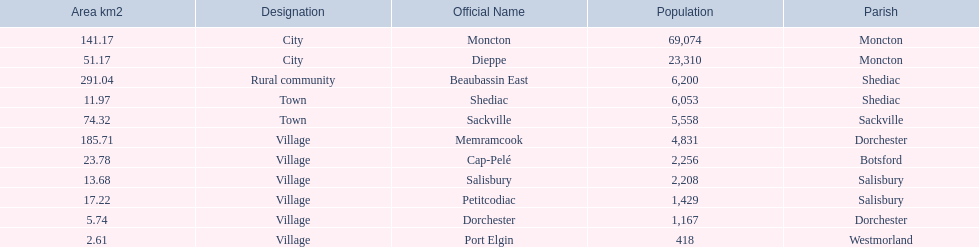Which city has the least area Port Elgin. 